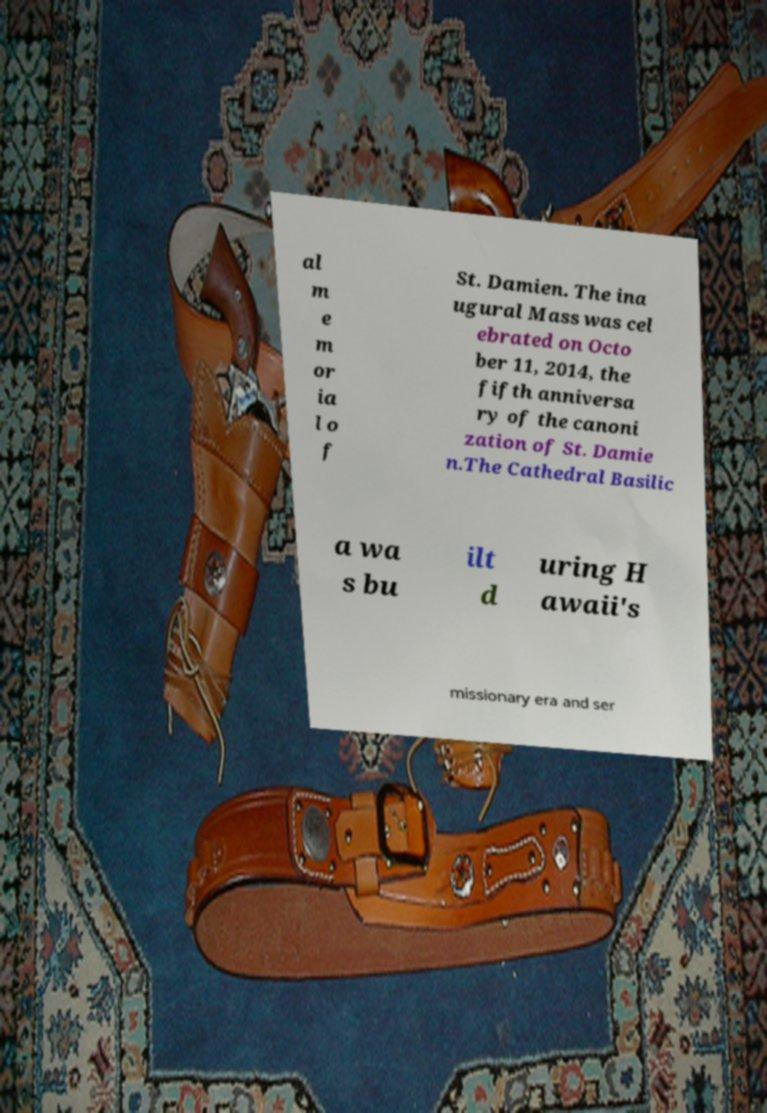Could you extract and type out the text from this image? al m e m or ia l o f St. Damien. The ina ugural Mass was cel ebrated on Octo ber 11, 2014, the fifth anniversa ry of the canoni zation of St. Damie n.The Cathedral Basilic a wa s bu ilt d uring H awaii's missionary era and ser 